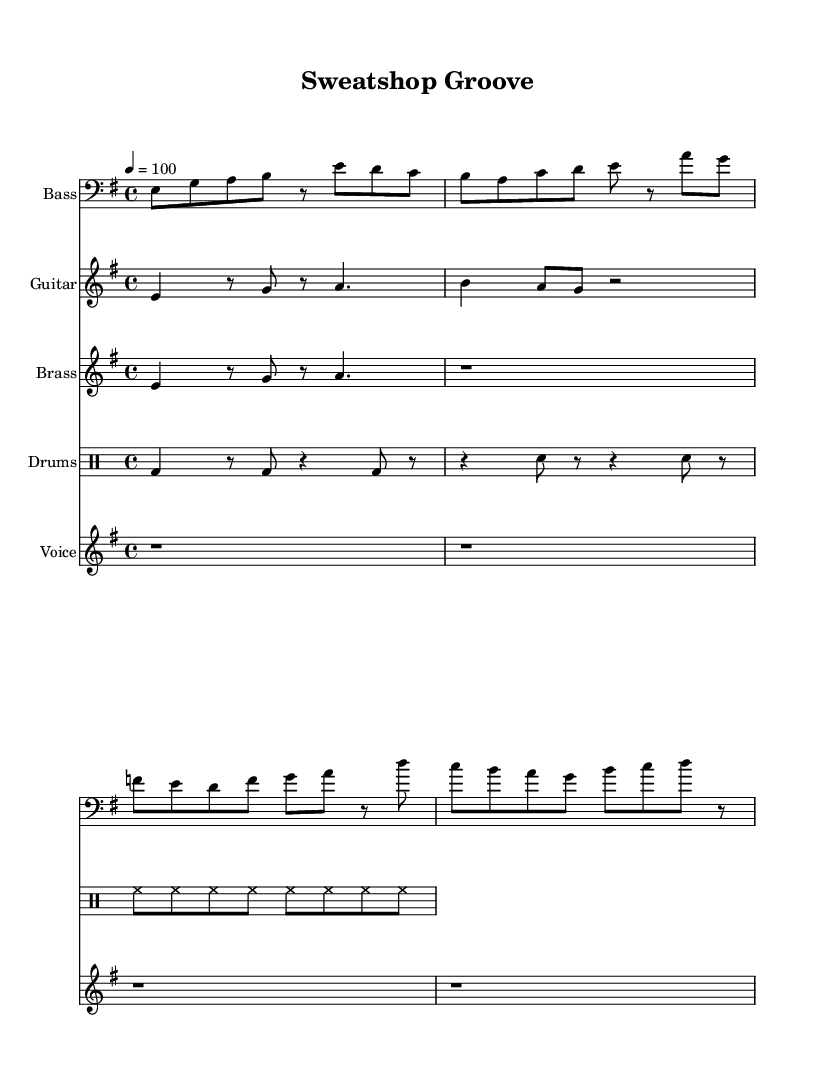What is the key signature of this music? The key signature is indicated on the staff at the beginning of the sheet music. It shows one flat, which means the key is E minor.
Answer: E minor What is the time signature of the piece? The time signature is found at the beginning of the music, denoted as 4/4, meaning there are four beats in each measure.
Answer: 4/4 What is the tempo marking for the music? The tempo marking is stated at the top of the sheet music, indicating the speed of the piece, which is 100 beats per minute.
Answer: 100 How many measures are there in the bass line? By counting the individual groups of notes separated by vertical lines (bar lines) in the bass line, we find there are eight measures.
Answer: Eight Which instrument plays the main riff? The main riff is presented in the staff labeled "Guitar," identifying it as the instrument performing this section of the music.
Answer: Guitar What lyrical theme is presented in the chorus? The lyrics of the chorus focus on the importance of worker's rights, as stated in the line about standing up and speaking out about the issues.
Answer: Worker’s rights Which vocal line is used in the piece? In the score, the vocal section is notated in the staff with the title "Voice," where the lyrics correspond to the melody of the song.
Answer: Voice 